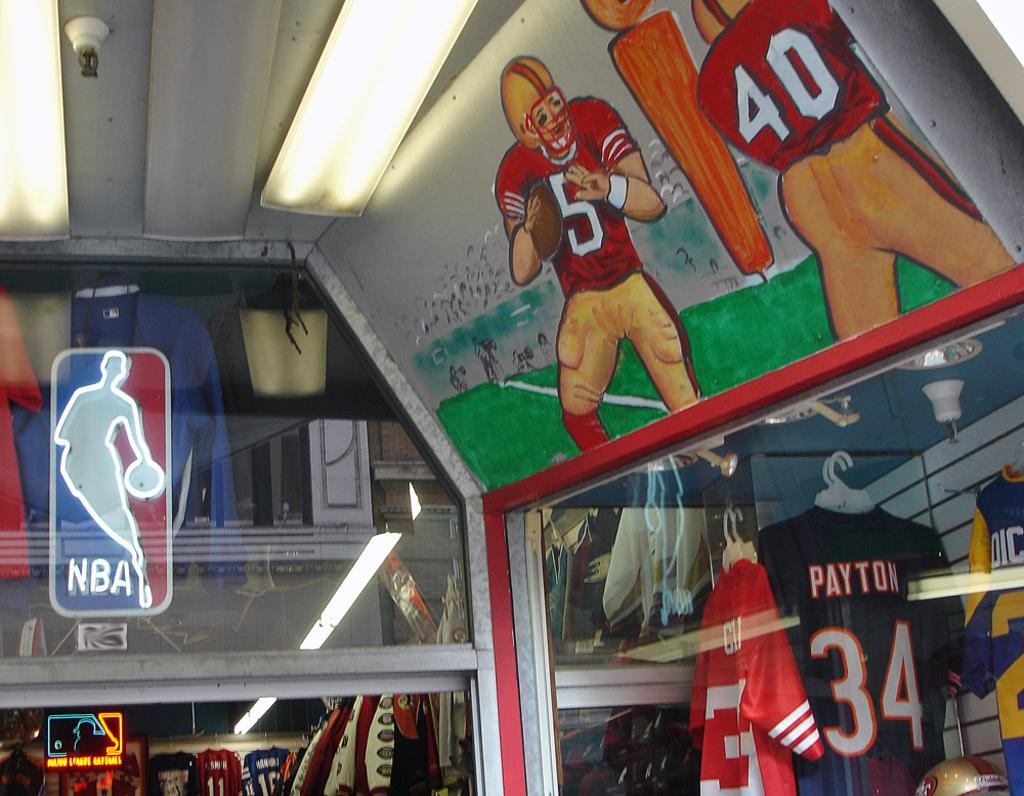<image>
Write a terse but informative summary of the picture. A painting of football players wearing numbers 5 and 40 respectively above some NFL jerseys. 